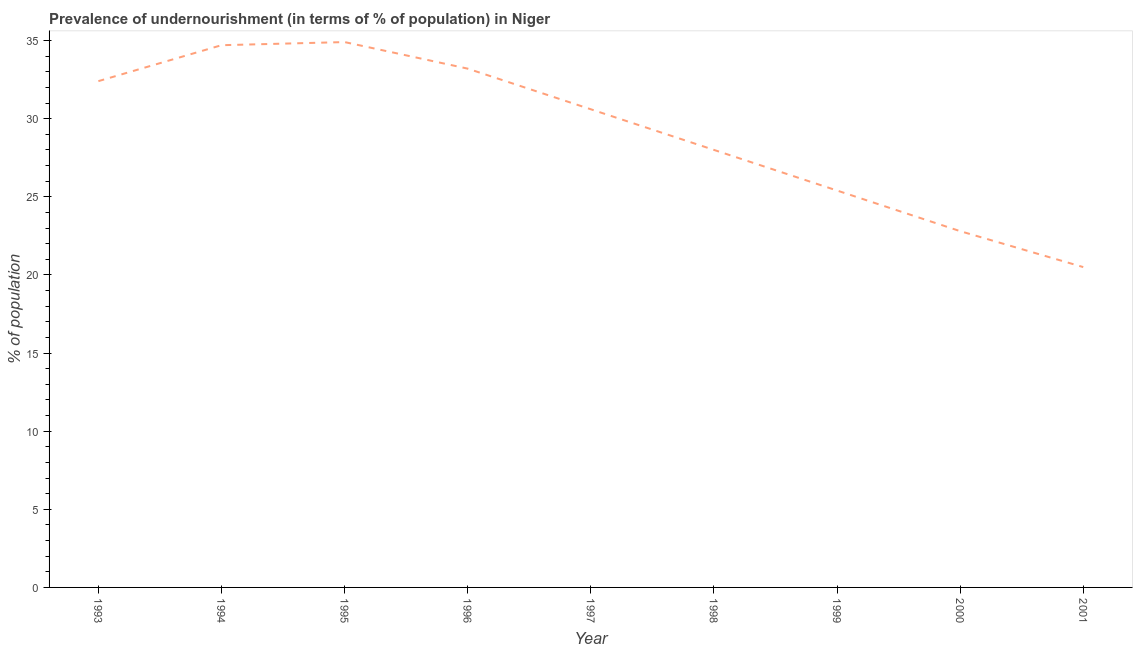What is the percentage of undernourished population in 1999?
Your response must be concise. 25.4. Across all years, what is the maximum percentage of undernourished population?
Provide a short and direct response. 34.9. In which year was the percentage of undernourished population minimum?
Offer a terse response. 2001. What is the sum of the percentage of undernourished population?
Give a very brief answer. 262.5. What is the difference between the percentage of undernourished population in 1993 and 1996?
Make the answer very short. -0.8. What is the average percentage of undernourished population per year?
Keep it short and to the point. 29.17. What is the median percentage of undernourished population?
Your answer should be compact. 30.6. What is the ratio of the percentage of undernourished population in 1993 to that in 1999?
Offer a terse response. 1.28. What is the difference between the highest and the second highest percentage of undernourished population?
Offer a very short reply. 0.2. Is the sum of the percentage of undernourished population in 1995 and 1996 greater than the maximum percentage of undernourished population across all years?
Offer a very short reply. Yes. What is the difference between the highest and the lowest percentage of undernourished population?
Keep it short and to the point. 14.4. In how many years, is the percentage of undernourished population greater than the average percentage of undernourished population taken over all years?
Offer a terse response. 5. How many lines are there?
Offer a terse response. 1. How many years are there in the graph?
Provide a short and direct response. 9. What is the difference between two consecutive major ticks on the Y-axis?
Provide a succinct answer. 5. Are the values on the major ticks of Y-axis written in scientific E-notation?
Make the answer very short. No. Does the graph contain any zero values?
Your response must be concise. No. What is the title of the graph?
Your answer should be compact. Prevalence of undernourishment (in terms of % of population) in Niger. What is the label or title of the X-axis?
Keep it short and to the point. Year. What is the label or title of the Y-axis?
Offer a very short reply. % of population. What is the % of population in 1993?
Offer a terse response. 32.4. What is the % of population in 1994?
Provide a short and direct response. 34.7. What is the % of population of 1995?
Give a very brief answer. 34.9. What is the % of population of 1996?
Your answer should be very brief. 33.2. What is the % of population in 1997?
Your answer should be compact. 30.6. What is the % of population of 1998?
Offer a very short reply. 28. What is the % of population of 1999?
Give a very brief answer. 25.4. What is the % of population in 2000?
Keep it short and to the point. 22.8. What is the difference between the % of population in 1993 and 1995?
Keep it short and to the point. -2.5. What is the difference between the % of population in 1993 and 1997?
Provide a succinct answer. 1.8. What is the difference between the % of population in 1993 and 1998?
Your response must be concise. 4.4. What is the difference between the % of population in 1993 and 2000?
Your answer should be compact. 9.6. What is the difference between the % of population in 1994 and 2000?
Give a very brief answer. 11.9. What is the difference between the % of population in 1995 and 2001?
Provide a succinct answer. 14.4. What is the difference between the % of population in 1996 and 1997?
Keep it short and to the point. 2.6. What is the difference between the % of population in 1996 and 2000?
Keep it short and to the point. 10.4. What is the difference between the % of population in 1996 and 2001?
Your response must be concise. 12.7. What is the difference between the % of population in 1997 and 1998?
Provide a short and direct response. 2.6. What is the difference between the % of population in 1997 and 1999?
Offer a very short reply. 5.2. What is the difference between the % of population in 1997 and 2001?
Make the answer very short. 10.1. What is the difference between the % of population in 1998 and 2001?
Make the answer very short. 7.5. What is the difference between the % of population in 1999 and 2000?
Provide a short and direct response. 2.6. What is the difference between the % of population in 2000 and 2001?
Your answer should be very brief. 2.3. What is the ratio of the % of population in 1993 to that in 1994?
Your answer should be very brief. 0.93. What is the ratio of the % of population in 1993 to that in 1995?
Your response must be concise. 0.93. What is the ratio of the % of population in 1993 to that in 1997?
Your answer should be very brief. 1.06. What is the ratio of the % of population in 1993 to that in 1998?
Offer a very short reply. 1.16. What is the ratio of the % of population in 1993 to that in 1999?
Your response must be concise. 1.28. What is the ratio of the % of population in 1993 to that in 2000?
Offer a terse response. 1.42. What is the ratio of the % of population in 1993 to that in 2001?
Your response must be concise. 1.58. What is the ratio of the % of population in 1994 to that in 1996?
Your answer should be compact. 1.04. What is the ratio of the % of population in 1994 to that in 1997?
Make the answer very short. 1.13. What is the ratio of the % of population in 1994 to that in 1998?
Provide a succinct answer. 1.24. What is the ratio of the % of population in 1994 to that in 1999?
Make the answer very short. 1.37. What is the ratio of the % of population in 1994 to that in 2000?
Your answer should be compact. 1.52. What is the ratio of the % of population in 1994 to that in 2001?
Your answer should be compact. 1.69. What is the ratio of the % of population in 1995 to that in 1996?
Offer a terse response. 1.05. What is the ratio of the % of population in 1995 to that in 1997?
Your answer should be compact. 1.14. What is the ratio of the % of population in 1995 to that in 1998?
Give a very brief answer. 1.25. What is the ratio of the % of population in 1995 to that in 1999?
Provide a short and direct response. 1.37. What is the ratio of the % of population in 1995 to that in 2000?
Give a very brief answer. 1.53. What is the ratio of the % of population in 1995 to that in 2001?
Your answer should be very brief. 1.7. What is the ratio of the % of population in 1996 to that in 1997?
Give a very brief answer. 1.08. What is the ratio of the % of population in 1996 to that in 1998?
Provide a short and direct response. 1.19. What is the ratio of the % of population in 1996 to that in 1999?
Provide a succinct answer. 1.31. What is the ratio of the % of population in 1996 to that in 2000?
Your answer should be very brief. 1.46. What is the ratio of the % of population in 1996 to that in 2001?
Provide a succinct answer. 1.62. What is the ratio of the % of population in 1997 to that in 1998?
Provide a short and direct response. 1.09. What is the ratio of the % of population in 1997 to that in 1999?
Offer a terse response. 1.21. What is the ratio of the % of population in 1997 to that in 2000?
Provide a short and direct response. 1.34. What is the ratio of the % of population in 1997 to that in 2001?
Your answer should be compact. 1.49. What is the ratio of the % of population in 1998 to that in 1999?
Offer a very short reply. 1.1. What is the ratio of the % of population in 1998 to that in 2000?
Offer a terse response. 1.23. What is the ratio of the % of population in 1998 to that in 2001?
Ensure brevity in your answer.  1.37. What is the ratio of the % of population in 1999 to that in 2000?
Offer a terse response. 1.11. What is the ratio of the % of population in 1999 to that in 2001?
Ensure brevity in your answer.  1.24. What is the ratio of the % of population in 2000 to that in 2001?
Offer a terse response. 1.11. 